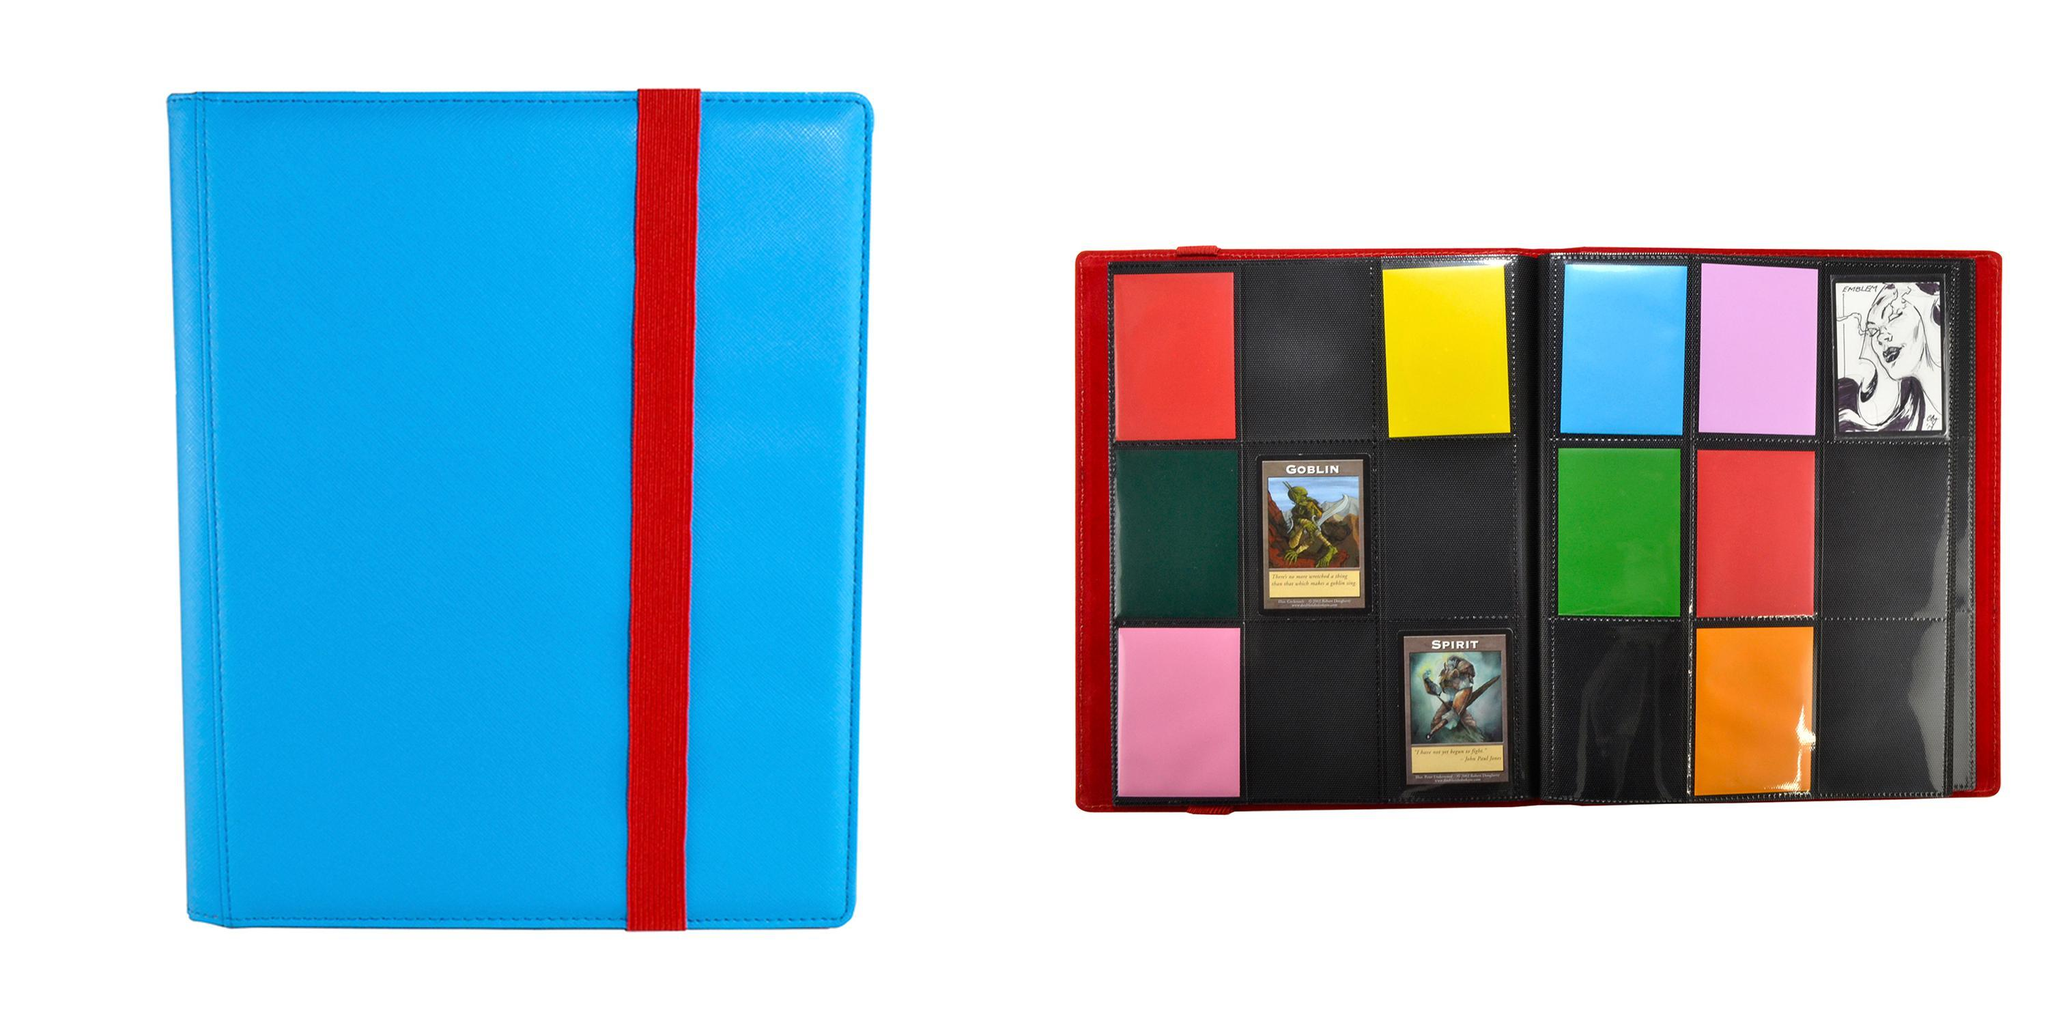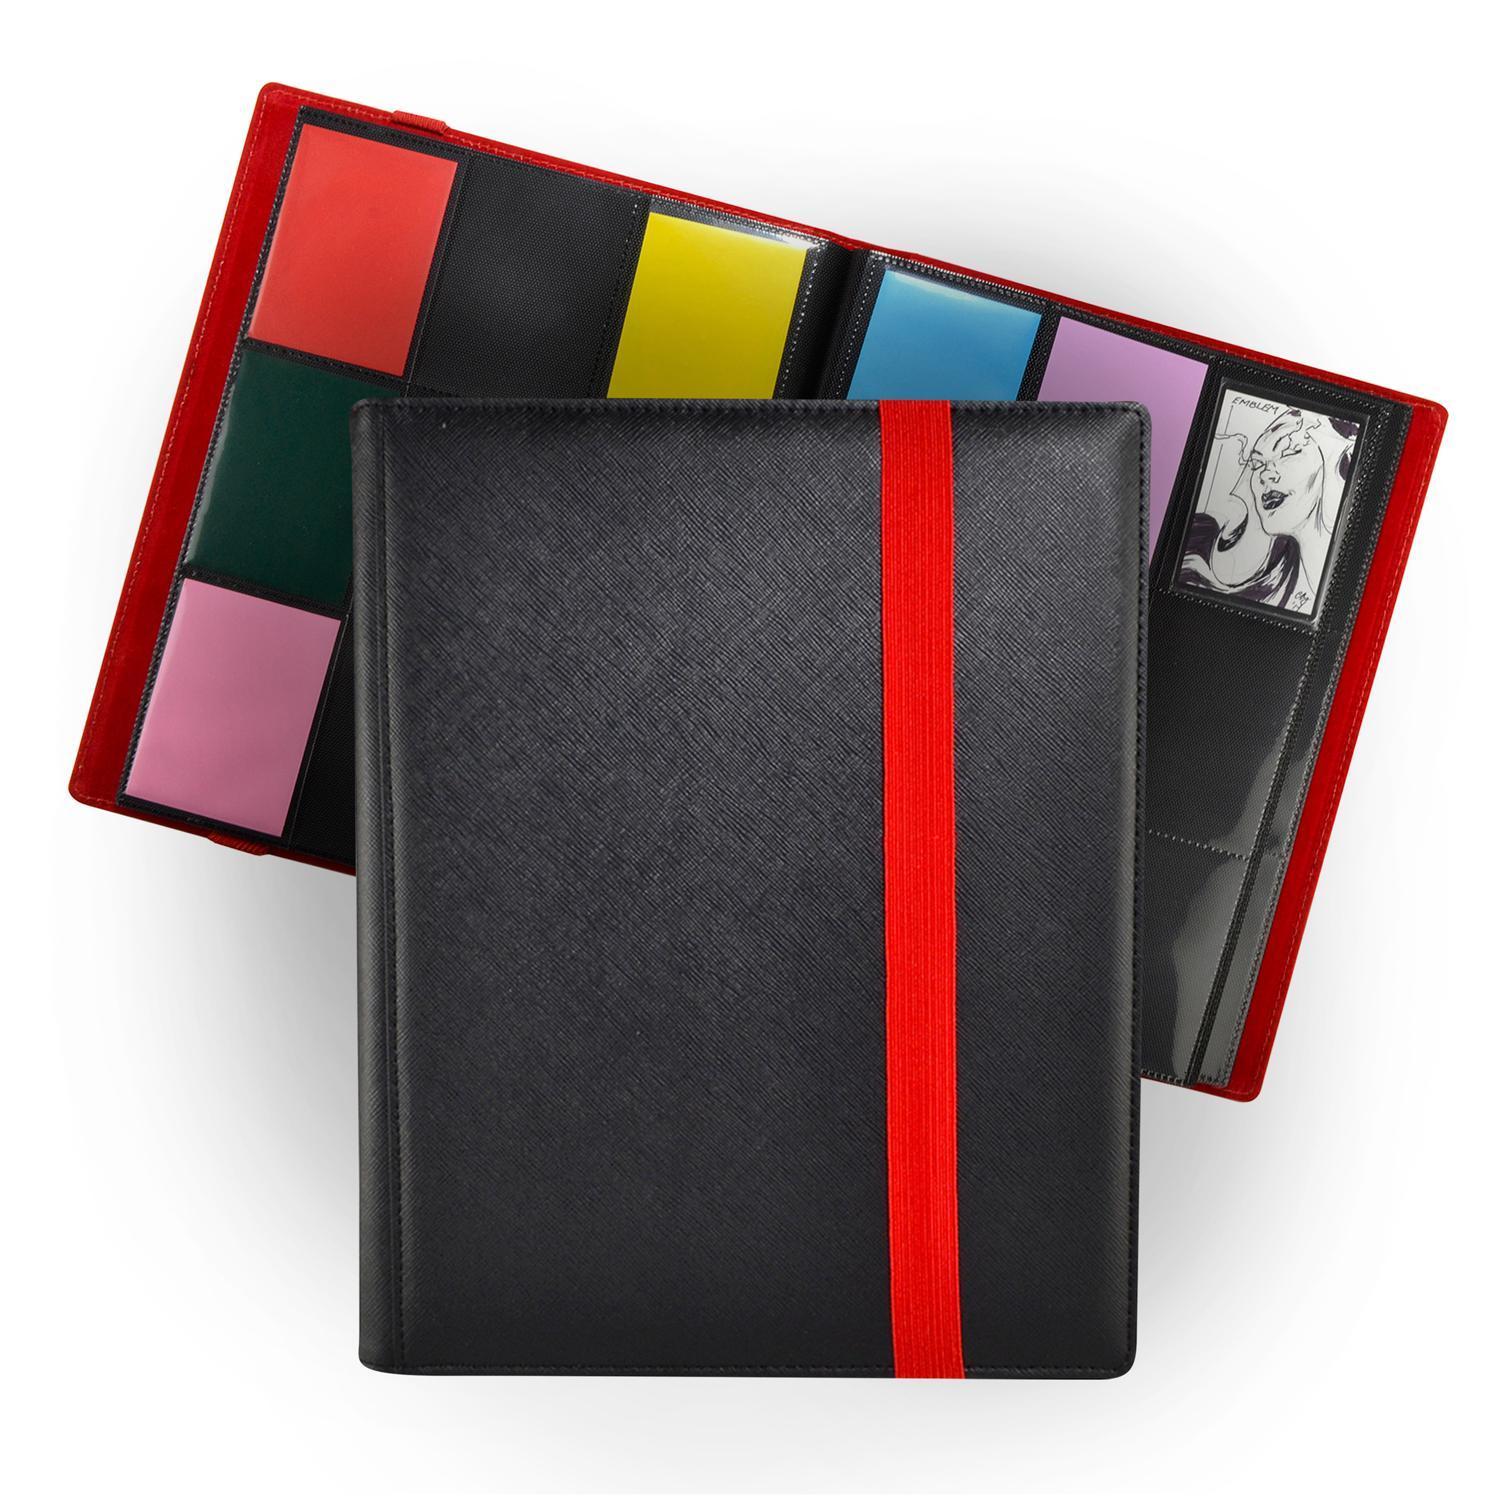The first image is the image on the left, the second image is the image on the right. Considering the images on both sides, is "In one image, a black album with red trim is show both open and closed." valid? Answer yes or no. Yes. 